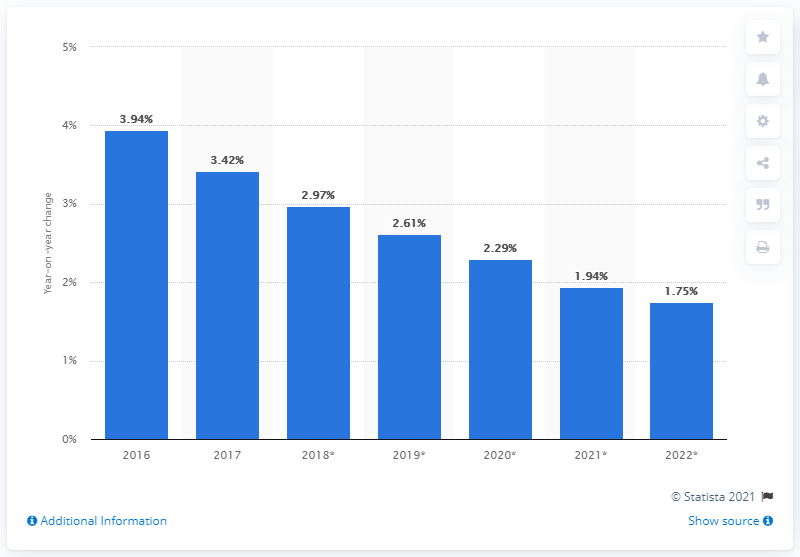Outline some significant characteristics in this image. In 2017, the number of mobile phone internet users increased by 3.42%. 